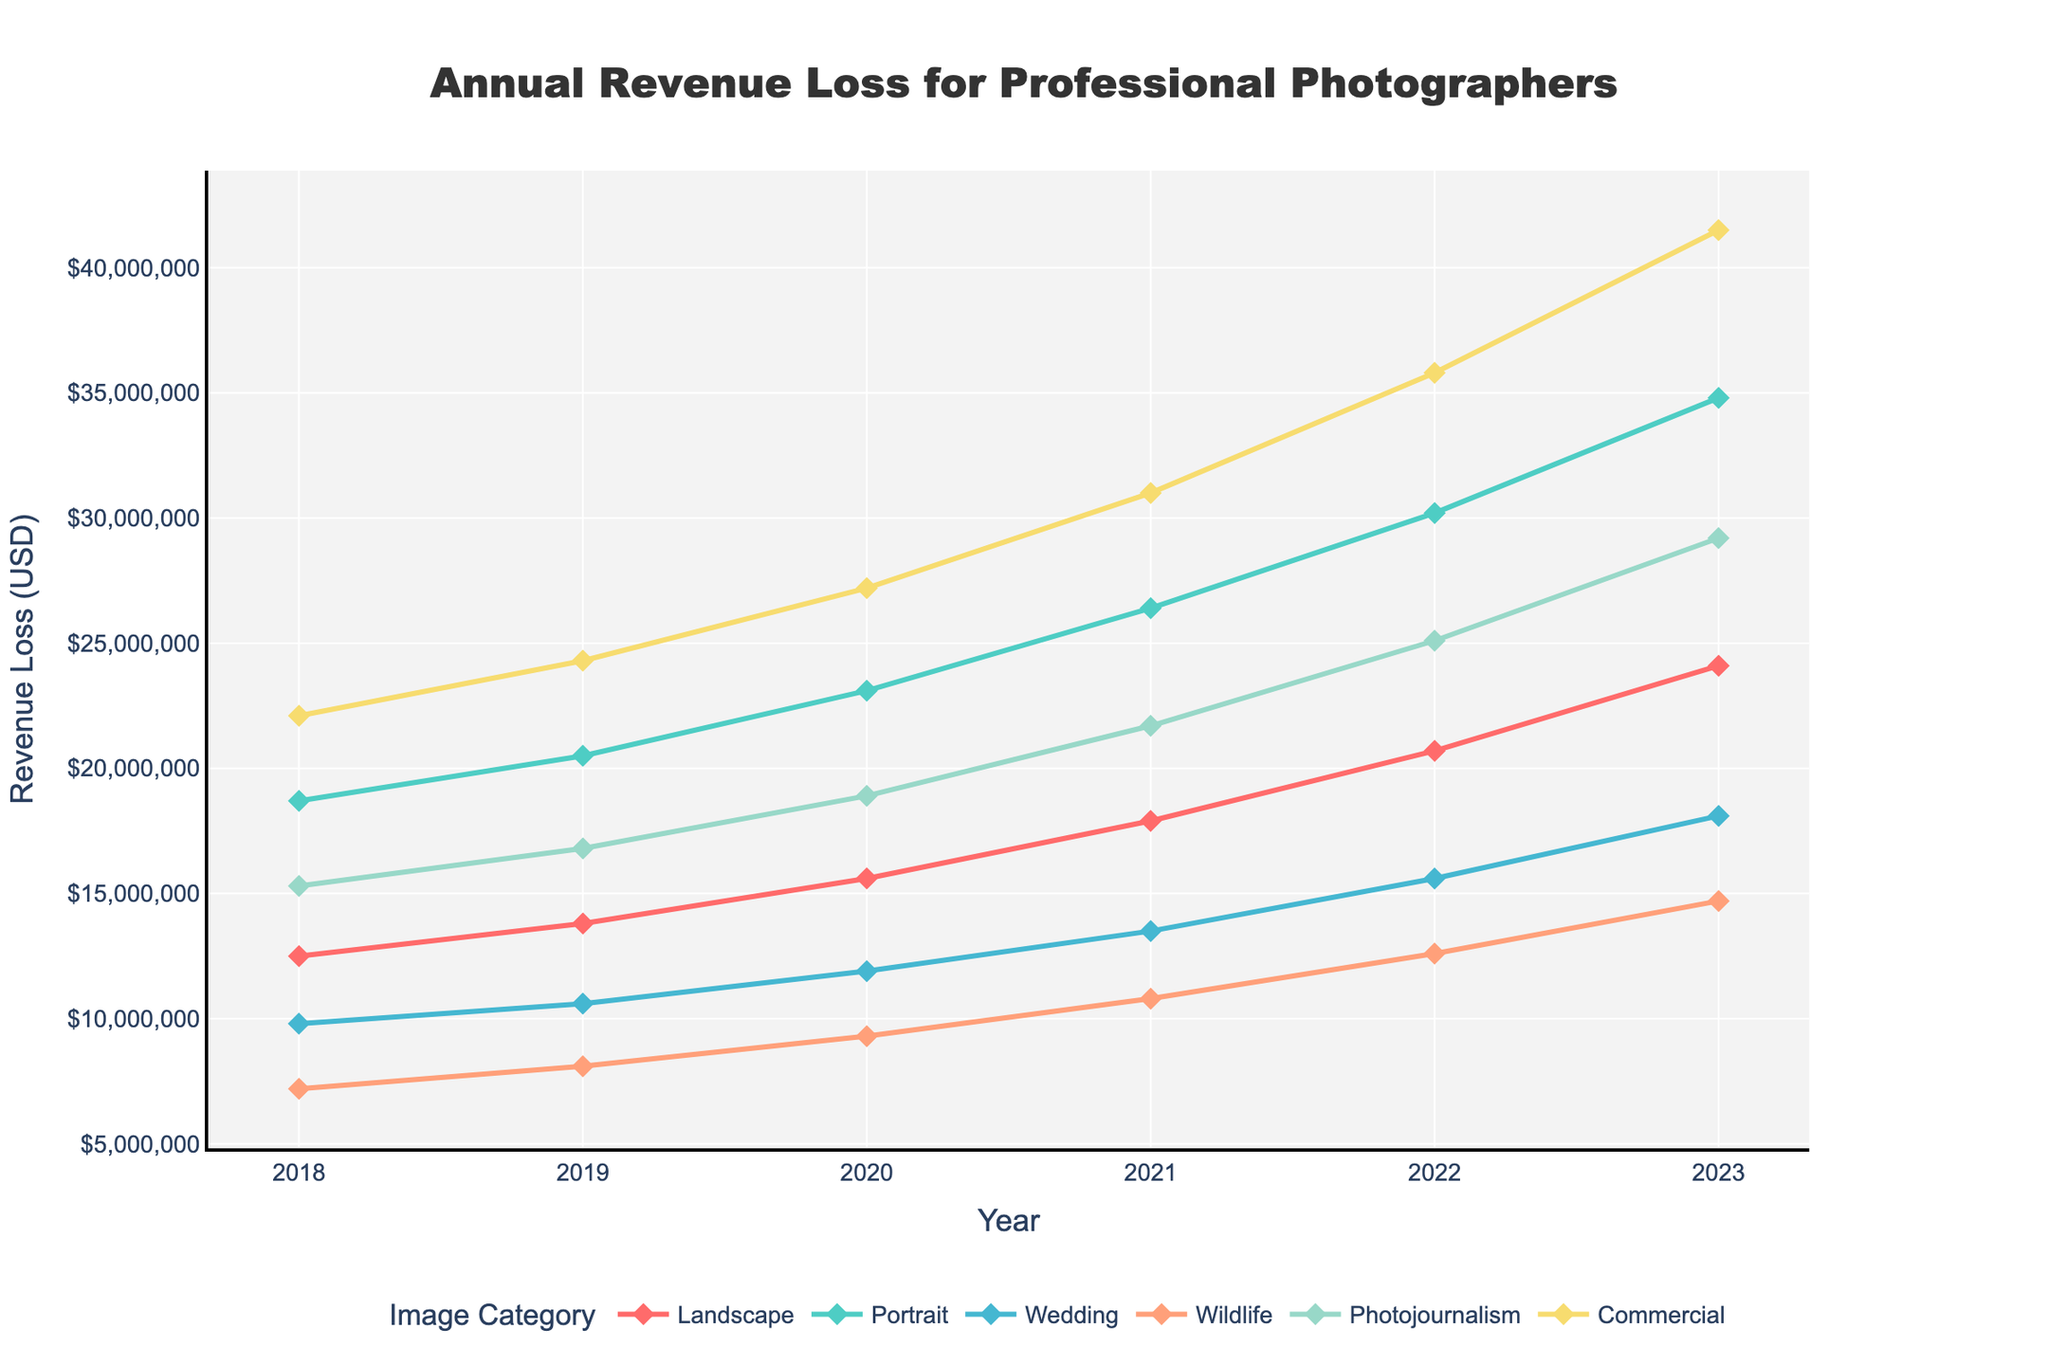What year did the revenue loss for Commercial images exceed $30000000? To find this, we look at the trend for Commercial images and see when it first surpasses the $30000000 mark. The loss exceeds this amount in 2022.
Answer: 2022 Which image category had the highest revenue loss in 2023? By examining the end of each trendline at 2023, we see that Commercial images have the highest revenue loss in 2023, reaching $41500000.
Answer: Commercial Did the revenue loss for Wildlife images ever surpass the loss for Wedding images? If so, in what year(s)? We compare the trendlines for Wildlife and Wedding images. Wildlife surpasses Wedding in 2018, 2019, and 2020.
Answer: 2018, 2019, 2020 How much did the revenue loss for Landscape images increase from 2018 to 2023? The revenue loss for Landscape images in 2018 is $12500000 and in 2023 is $24100000. The increase is $24100000 - $12500000 = $11600000.
Answer: $11600000 Which image category had the smallest revenue loss in 2020? By checking the values for all image categories in 2020, Wildlife images had the smallest loss of $9300000.
Answer: Wildlife What's the total revenue loss across all image categories in 2021? Sum the revenue losses for all categories in 2021: $17900000 (Landscape) + $26400000 (Portrait) + $13500000 (Wedding) + $10800000 (Wildlife) + $21700000 (Photojournalism) + $31000000 (Commercial) = $121300000
Answer: $121300000 Compare the revenue losses for Portrait and Photojournalism images in 2019. Which one had a higher loss and by how much? Photojournalism had a loss of $16800000 while Portrait had $20500000 in 2019. The difference is $20500000 - $16800000 = $3700000.
Answer: Portrait, $3700000 Observing the trends, which category appears to have the most consistent year-over-year revenue loss increase? By visually comparing the slope of each category's line, Commercial images exhibit the steepest and most consistent year-over-year increase.
Answer: Commercial How did the revenue loss for Wedding images change from 2020 to 2021? The revenue loss for Wedding images in 2020 is $11900000 and in 2021 is $13500000. The change is $13500000 - $11900000 = $1600000.
Answer: Increased by $1600000 Which two categories showed the closest revenue loss values in 2020? By comparing values in 2020, Wedding ($11900000) and Wildlife ($9300000) are closest with a difference of $2600000.
Answer: Wedding and Wildlife 